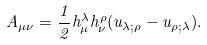Convert formula to latex. <formula><loc_0><loc_0><loc_500><loc_500>A _ { \mu \nu } = \frac { 1 } { 2 } h ^ { \lambda } _ { \mu } h ^ { \rho } _ { \nu } ( u _ { \lambda ; \rho } - u _ { \rho ; \lambda } ) .</formula> 